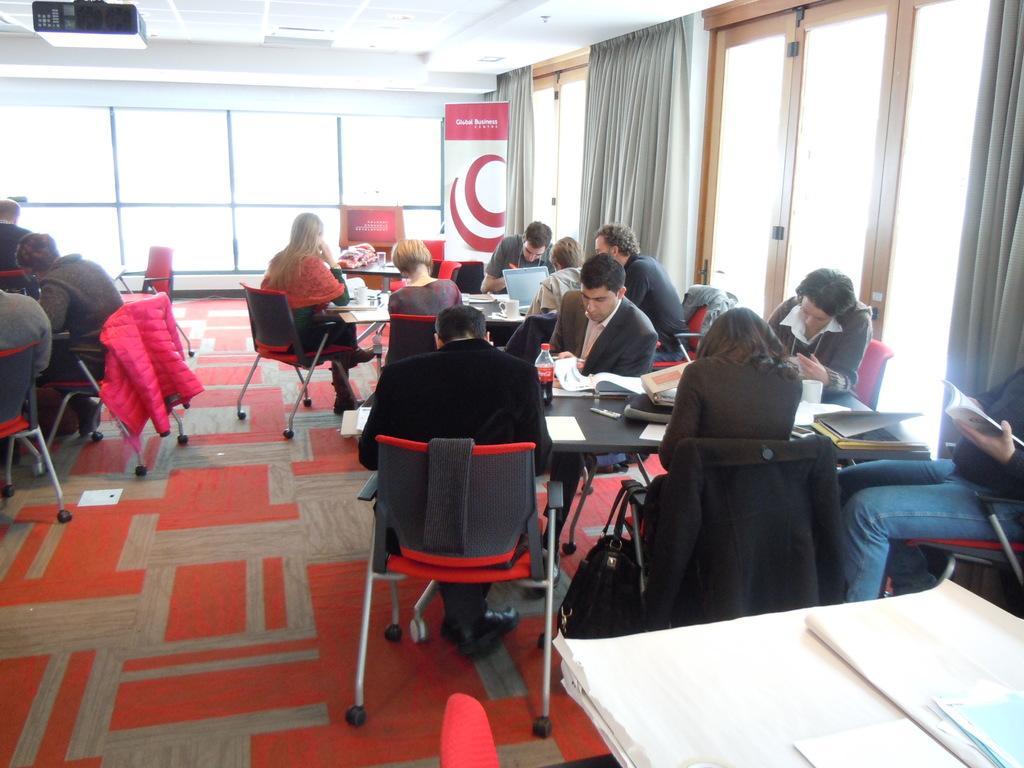Describe this image in one or two sentences. In this image there are group of people who are sitting on a chair on the right side there is one window and curtains are there on the left side there are some people who are sitting in the bottom of the right corner there are some papers on the top of the image there is ceiling and on the left side there is one projector. 